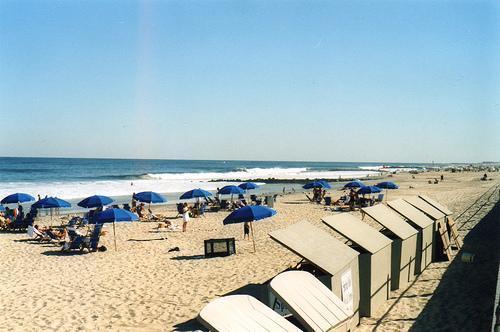How many blue umbrellas can be seen?
Give a very brief answer. 13. How many umbrellas are there?
Give a very brief answer. 13. 